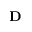<formula> <loc_0><loc_0><loc_500><loc_500>D</formula> 